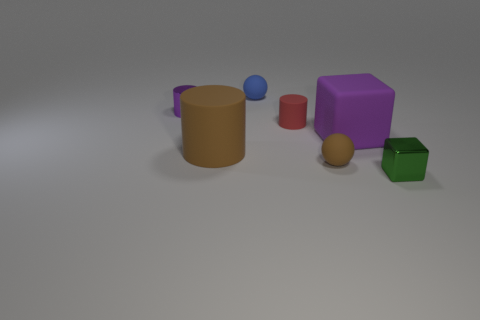Add 1 large blue cylinders. How many objects exist? 8 Subtract all cylinders. How many objects are left? 4 Add 6 small green metal objects. How many small green metal objects exist? 7 Subtract 1 purple cylinders. How many objects are left? 6 Subtract all large cylinders. Subtract all matte things. How many objects are left? 1 Add 1 tiny cylinders. How many tiny cylinders are left? 3 